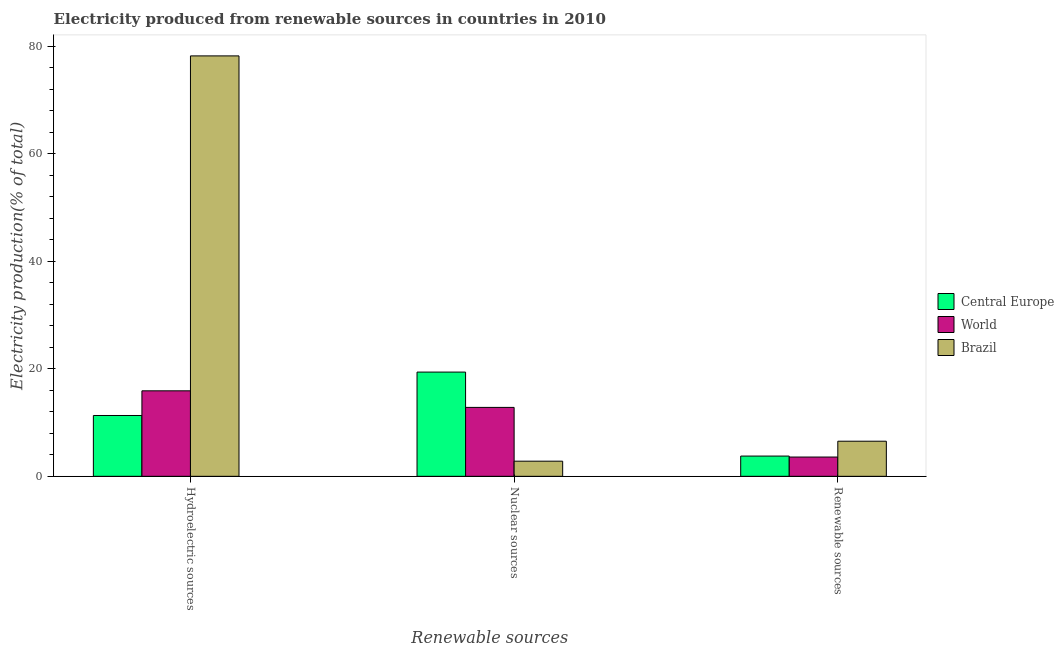How many different coloured bars are there?
Give a very brief answer. 3. Are the number of bars per tick equal to the number of legend labels?
Your answer should be very brief. Yes. How many bars are there on the 3rd tick from the left?
Make the answer very short. 3. How many bars are there on the 1st tick from the right?
Offer a terse response. 3. What is the label of the 3rd group of bars from the left?
Provide a short and direct response. Renewable sources. What is the percentage of electricity produced by hydroelectric sources in World?
Ensure brevity in your answer.  15.9. Across all countries, what is the maximum percentage of electricity produced by hydroelectric sources?
Provide a short and direct response. 78.2. Across all countries, what is the minimum percentage of electricity produced by nuclear sources?
Ensure brevity in your answer.  2.82. In which country was the percentage of electricity produced by renewable sources minimum?
Provide a short and direct response. World. What is the total percentage of electricity produced by hydroelectric sources in the graph?
Give a very brief answer. 105.41. What is the difference between the percentage of electricity produced by nuclear sources in Brazil and that in Central Europe?
Ensure brevity in your answer.  -16.57. What is the difference between the percentage of electricity produced by hydroelectric sources in World and the percentage of electricity produced by nuclear sources in Brazil?
Give a very brief answer. 13.09. What is the average percentage of electricity produced by nuclear sources per country?
Provide a short and direct response. 11.67. What is the difference between the percentage of electricity produced by nuclear sources and percentage of electricity produced by renewable sources in Brazil?
Make the answer very short. -3.71. What is the ratio of the percentage of electricity produced by renewable sources in Brazil to that in Central Europe?
Provide a short and direct response. 1.73. Is the difference between the percentage of electricity produced by hydroelectric sources in Central Europe and World greater than the difference between the percentage of electricity produced by nuclear sources in Central Europe and World?
Give a very brief answer. No. What is the difference between the highest and the second highest percentage of electricity produced by hydroelectric sources?
Make the answer very short. 62.29. What is the difference between the highest and the lowest percentage of electricity produced by renewable sources?
Keep it short and to the point. 2.94. Is the sum of the percentage of electricity produced by nuclear sources in Brazil and World greater than the maximum percentage of electricity produced by renewable sources across all countries?
Give a very brief answer. Yes. What does the 3rd bar from the right in Hydroelectric sources represents?
Ensure brevity in your answer.  Central Europe. Are all the bars in the graph horizontal?
Make the answer very short. No. Does the graph contain grids?
Your answer should be compact. No. How are the legend labels stacked?
Ensure brevity in your answer.  Vertical. What is the title of the graph?
Provide a short and direct response. Electricity produced from renewable sources in countries in 2010. Does "Papua New Guinea" appear as one of the legend labels in the graph?
Ensure brevity in your answer.  No. What is the label or title of the X-axis?
Make the answer very short. Renewable sources. What is the label or title of the Y-axis?
Keep it short and to the point. Electricity production(% of total). What is the Electricity production(% of total) in Central Europe in Hydroelectric sources?
Ensure brevity in your answer.  11.31. What is the Electricity production(% of total) in World in Hydroelectric sources?
Keep it short and to the point. 15.9. What is the Electricity production(% of total) in Brazil in Hydroelectric sources?
Give a very brief answer. 78.2. What is the Electricity production(% of total) of Central Europe in Nuclear sources?
Your response must be concise. 19.39. What is the Electricity production(% of total) in World in Nuclear sources?
Your response must be concise. 12.82. What is the Electricity production(% of total) of Brazil in Nuclear sources?
Ensure brevity in your answer.  2.82. What is the Electricity production(% of total) of Central Europe in Renewable sources?
Offer a terse response. 3.77. What is the Electricity production(% of total) in World in Renewable sources?
Provide a short and direct response. 3.58. What is the Electricity production(% of total) of Brazil in Renewable sources?
Your answer should be compact. 6.53. Across all Renewable sources, what is the maximum Electricity production(% of total) of Central Europe?
Ensure brevity in your answer.  19.39. Across all Renewable sources, what is the maximum Electricity production(% of total) in World?
Ensure brevity in your answer.  15.9. Across all Renewable sources, what is the maximum Electricity production(% of total) of Brazil?
Offer a very short reply. 78.2. Across all Renewable sources, what is the minimum Electricity production(% of total) of Central Europe?
Give a very brief answer. 3.77. Across all Renewable sources, what is the minimum Electricity production(% of total) of World?
Ensure brevity in your answer.  3.58. Across all Renewable sources, what is the minimum Electricity production(% of total) in Brazil?
Your answer should be very brief. 2.82. What is the total Electricity production(% of total) in Central Europe in the graph?
Your answer should be very brief. 34.46. What is the total Electricity production(% of total) in World in the graph?
Offer a terse response. 32.3. What is the total Electricity production(% of total) in Brazil in the graph?
Offer a terse response. 87.54. What is the difference between the Electricity production(% of total) of Central Europe in Hydroelectric sources and that in Nuclear sources?
Provide a succinct answer. -8.07. What is the difference between the Electricity production(% of total) of World in Hydroelectric sources and that in Nuclear sources?
Give a very brief answer. 3.08. What is the difference between the Electricity production(% of total) of Brazil in Hydroelectric sources and that in Nuclear sources?
Your answer should be very brief. 75.38. What is the difference between the Electricity production(% of total) in Central Europe in Hydroelectric sources and that in Renewable sources?
Offer a terse response. 7.55. What is the difference between the Electricity production(% of total) of World in Hydroelectric sources and that in Renewable sources?
Ensure brevity in your answer.  12.32. What is the difference between the Electricity production(% of total) in Brazil in Hydroelectric sources and that in Renewable sources?
Ensure brevity in your answer.  71.67. What is the difference between the Electricity production(% of total) of Central Europe in Nuclear sources and that in Renewable sources?
Provide a succinct answer. 15.62. What is the difference between the Electricity production(% of total) of World in Nuclear sources and that in Renewable sources?
Provide a succinct answer. 9.23. What is the difference between the Electricity production(% of total) of Brazil in Nuclear sources and that in Renewable sources?
Ensure brevity in your answer.  -3.71. What is the difference between the Electricity production(% of total) of Central Europe in Hydroelectric sources and the Electricity production(% of total) of World in Nuclear sources?
Your response must be concise. -1.51. What is the difference between the Electricity production(% of total) of Central Europe in Hydroelectric sources and the Electricity production(% of total) of Brazil in Nuclear sources?
Offer a very short reply. 8.5. What is the difference between the Electricity production(% of total) of World in Hydroelectric sources and the Electricity production(% of total) of Brazil in Nuclear sources?
Offer a very short reply. 13.09. What is the difference between the Electricity production(% of total) in Central Europe in Hydroelectric sources and the Electricity production(% of total) in World in Renewable sources?
Keep it short and to the point. 7.73. What is the difference between the Electricity production(% of total) in Central Europe in Hydroelectric sources and the Electricity production(% of total) in Brazil in Renewable sources?
Your answer should be very brief. 4.78. What is the difference between the Electricity production(% of total) of World in Hydroelectric sources and the Electricity production(% of total) of Brazil in Renewable sources?
Keep it short and to the point. 9.37. What is the difference between the Electricity production(% of total) of Central Europe in Nuclear sources and the Electricity production(% of total) of World in Renewable sources?
Provide a succinct answer. 15.8. What is the difference between the Electricity production(% of total) in Central Europe in Nuclear sources and the Electricity production(% of total) in Brazil in Renewable sources?
Keep it short and to the point. 12.86. What is the difference between the Electricity production(% of total) in World in Nuclear sources and the Electricity production(% of total) in Brazil in Renewable sources?
Keep it short and to the point. 6.29. What is the average Electricity production(% of total) of Central Europe per Renewable sources?
Make the answer very short. 11.49. What is the average Electricity production(% of total) of World per Renewable sources?
Your answer should be compact. 10.77. What is the average Electricity production(% of total) of Brazil per Renewable sources?
Your answer should be very brief. 29.18. What is the difference between the Electricity production(% of total) in Central Europe and Electricity production(% of total) in World in Hydroelectric sources?
Keep it short and to the point. -4.59. What is the difference between the Electricity production(% of total) of Central Europe and Electricity production(% of total) of Brazil in Hydroelectric sources?
Ensure brevity in your answer.  -66.88. What is the difference between the Electricity production(% of total) in World and Electricity production(% of total) in Brazil in Hydroelectric sources?
Provide a short and direct response. -62.29. What is the difference between the Electricity production(% of total) in Central Europe and Electricity production(% of total) in World in Nuclear sources?
Your response must be concise. 6.57. What is the difference between the Electricity production(% of total) in Central Europe and Electricity production(% of total) in Brazil in Nuclear sources?
Your response must be concise. 16.57. What is the difference between the Electricity production(% of total) in World and Electricity production(% of total) in Brazil in Nuclear sources?
Ensure brevity in your answer.  10. What is the difference between the Electricity production(% of total) in Central Europe and Electricity production(% of total) in World in Renewable sources?
Offer a very short reply. 0.18. What is the difference between the Electricity production(% of total) in Central Europe and Electricity production(% of total) in Brazil in Renewable sources?
Your answer should be compact. -2.76. What is the difference between the Electricity production(% of total) of World and Electricity production(% of total) of Brazil in Renewable sources?
Offer a terse response. -2.94. What is the ratio of the Electricity production(% of total) in Central Europe in Hydroelectric sources to that in Nuclear sources?
Make the answer very short. 0.58. What is the ratio of the Electricity production(% of total) of World in Hydroelectric sources to that in Nuclear sources?
Provide a succinct answer. 1.24. What is the ratio of the Electricity production(% of total) of Brazil in Hydroelectric sources to that in Nuclear sources?
Your answer should be very brief. 27.77. What is the ratio of the Electricity production(% of total) in Central Europe in Hydroelectric sources to that in Renewable sources?
Your response must be concise. 3. What is the ratio of the Electricity production(% of total) of World in Hydroelectric sources to that in Renewable sources?
Make the answer very short. 4.44. What is the ratio of the Electricity production(% of total) of Brazil in Hydroelectric sources to that in Renewable sources?
Offer a very short reply. 11.98. What is the ratio of the Electricity production(% of total) of Central Europe in Nuclear sources to that in Renewable sources?
Keep it short and to the point. 5.15. What is the ratio of the Electricity production(% of total) of World in Nuclear sources to that in Renewable sources?
Give a very brief answer. 3.58. What is the ratio of the Electricity production(% of total) in Brazil in Nuclear sources to that in Renewable sources?
Offer a very short reply. 0.43. What is the difference between the highest and the second highest Electricity production(% of total) in Central Europe?
Offer a terse response. 8.07. What is the difference between the highest and the second highest Electricity production(% of total) in World?
Give a very brief answer. 3.08. What is the difference between the highest and the second highest Electricity production(% of total) in Brazil?
Your response must be concise. 71.67. What is the difference between the highest and the lowest Electricity production(% of total) of Central Europe?
Offer a terse response. 15.62. What is the difference between the highest and the lowest Electricity production(% of total) in World?
Your response must be concise. 12.32. What is the difference between the highest and the lowest Electricity production(% of total) of Brazil?
Your answer should be compact. 75.38. 